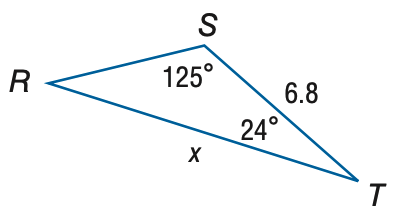Question: Find x. Round to the nearest tenth.
Choices:
A. 3.4
B. 4.3
C. 10.8
D. 13.7
Answer with the letter. Answer: C 